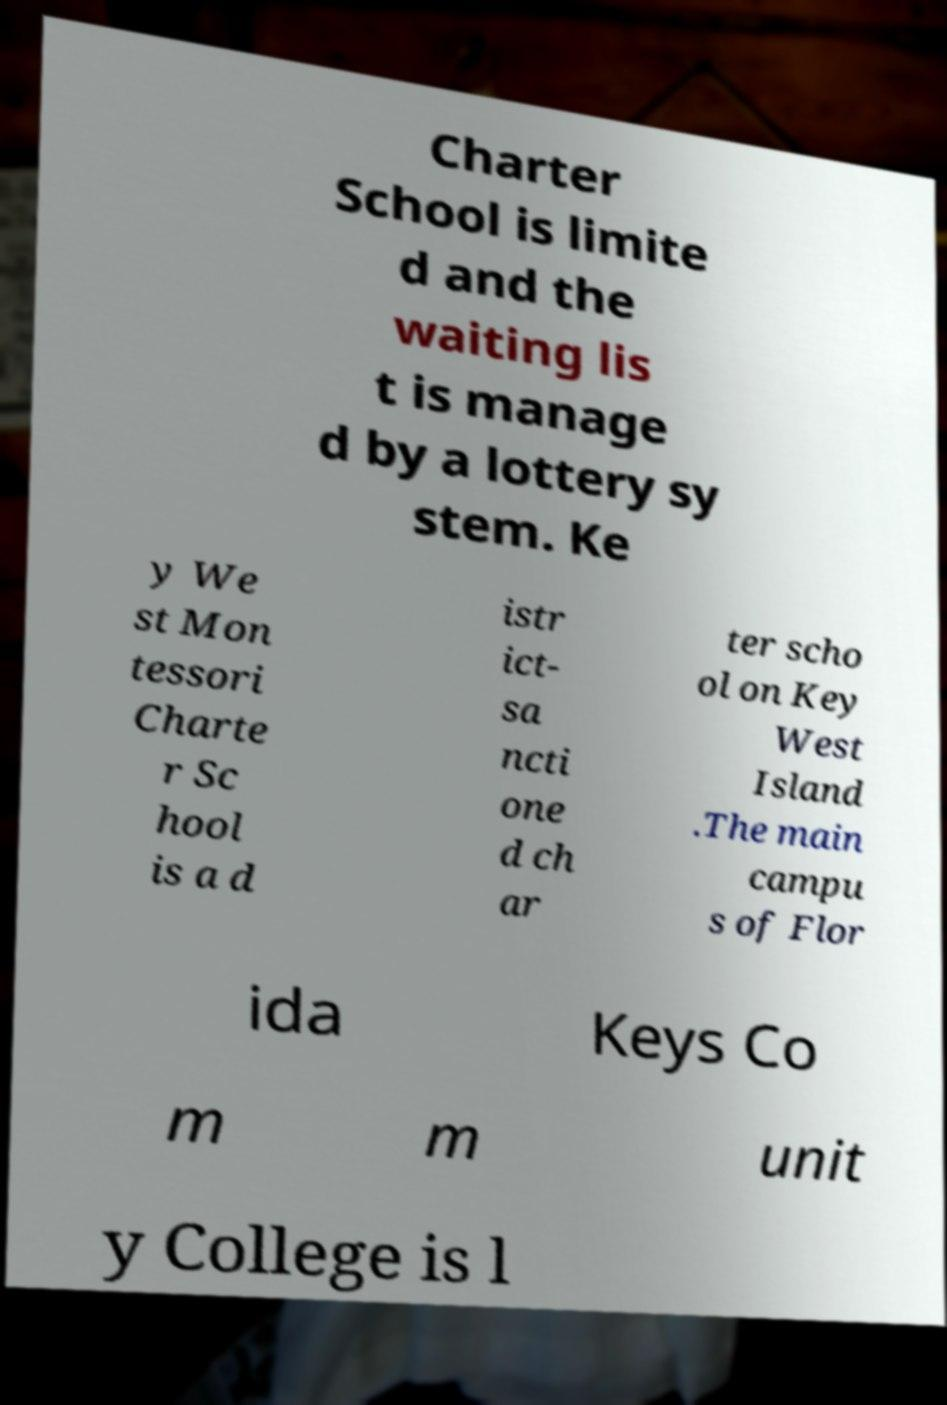There's text embedded in this image that I need extracted. Can you transcribe it verbatim? Charter School is limite d and the waiting lis t is manage d by a lottery sy stem. Ke y We st Mon tessori Charte r Sc hool is a d istr ict- sa ncti one d ch ar ter scho ol on Key West Island .The main campu s of Flor ida Keys Co m m unit y College is l 